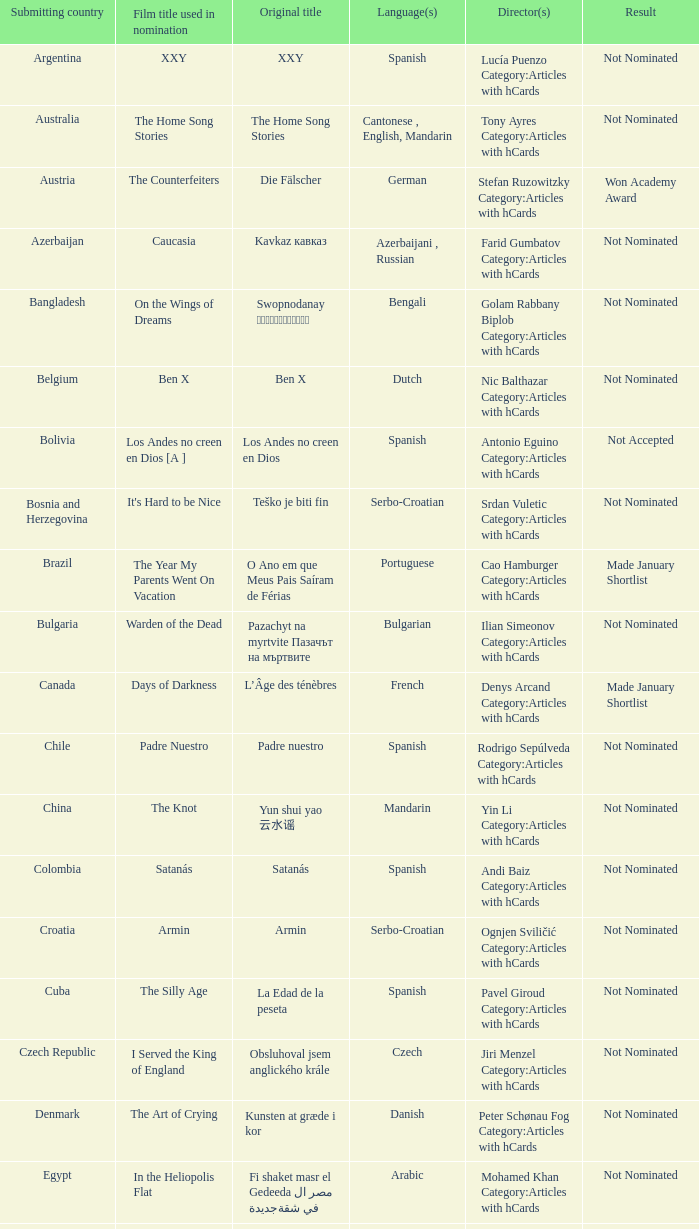What was the name of the film from lebanon? Caramel. 